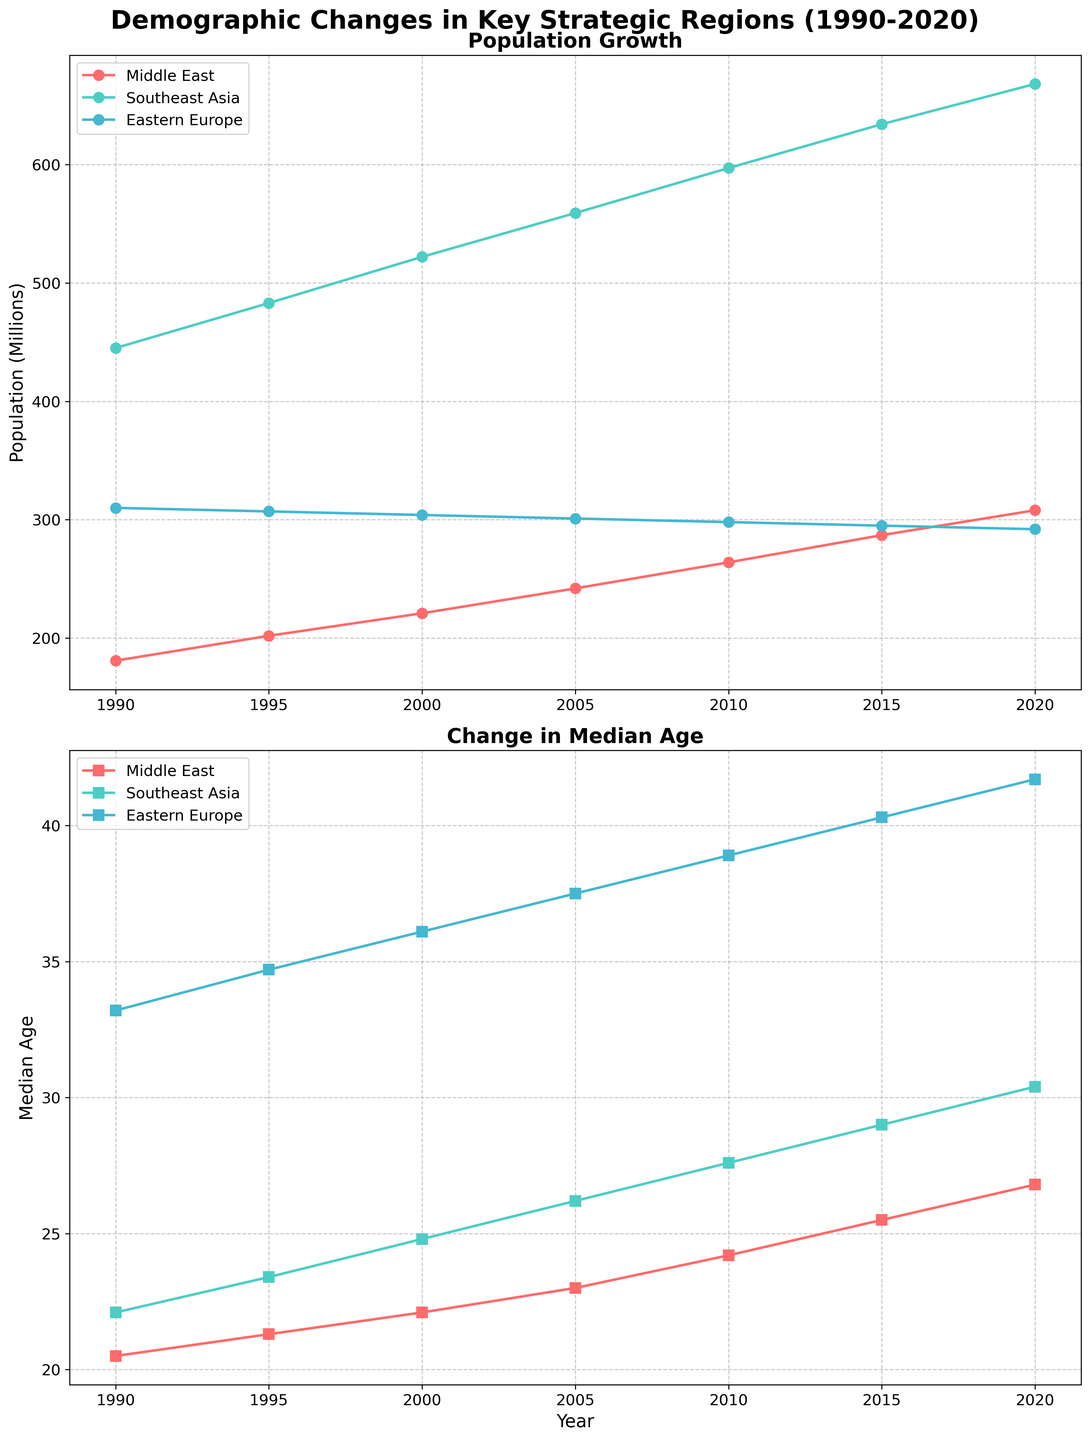What is the title of the figure? The title appears at the top of the figure. It reads "Demographic Changes in Key Strategic Regions (1990-2020)".
Answer: Demographic Changes in Key Strategic Regions (1990-2020) What is the population of the Middle East in 2005? Look at the first subplot corresponding to "Population Growth" and find the data point for the Middle East in 2005. The marker value indicates the population.
Answer: 242 million How did the median age in Southeast Asia change from 1990 to 2020? On the second subplot, observe the changes in the line corresponding to Southeast Asia's median age from 1990 to 2020. The values go from 22.1 to 30.4.
Answer: Increased from 22.1 to 30.4 Which region had the highest population increase from 1990 to 2020? Calculate the population difference from 1990 to 2020 for each region by looking at the first subplot. Compare the changes. Middle East: 308M-181M, Southeast Asia: 668M-445M, Eastern Europe: 292M-310M.
Answer: Southeast Asia Compare the median ages of Eastern Europe and Middle East in 2015. On the second subplot, compare the data points for 2015 for both Eastern Europe and Middle East. Eastern Europe: 40.3, Middle East: 25.5.
Answer: Eastern Europe had a higher median age What is the overall trend of population growth in the Middle East from 1990 to 2020? View the line corresponding to the Middle East in the first subplot. The population consistently increases from 1990 to 2020.
Answer: Increasing How does the median age trend in Eastern Europe compare to that in the Middle East from 1990 to 2020? On the second subplot, the median age in Eastern Europe is consistently higher than that of the Middle East and increases at a similar rate.
Answer: Both increase, but Eastern Europe is higher What was the average population of Southeast Asia from 1995 to 2005? Sum the populations for Southeast Asia from 1995 (483M), 2000 (522M), and 2005 (559M), divide by the number of years (3). (483 + 522 + 559) / 3.
Answer: 521.3 million Which region experienced a decline in population between 1990 and 2020? In the first subplot, look for any decreasing trend. Eastern Europe's line slightly declines from 310M to 292M.
Answer: Eastern Europe What are the two subplots in the figure titled? The titles are located above each subplot. The first one is "Population Growth" and the second one is "Change in Median Age".
Answer: Population Growth, Change in Median Age 